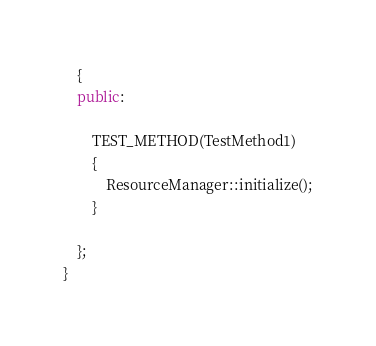Convert code to text. <code><loc_0><loc_0><loc_500><loc_500><_C++_>	{
	public:

		TEST_METHOD(TestMethod1)
		{
			ResourceManager::initialize();
		}

	};
}</code> 